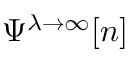<formula> <loc_0><loc_0><loc_500><loc_500>\Psi ^ { \lambda \to \infty } [ n ]</formula> 